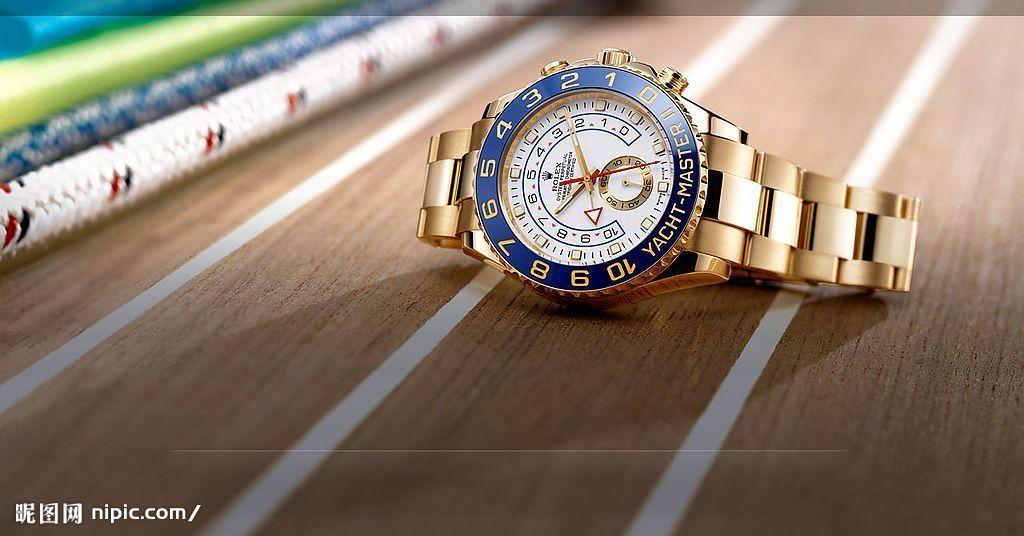<image>
Share a concise interpretation of the image provided. The gold and white watch is from Rolex 